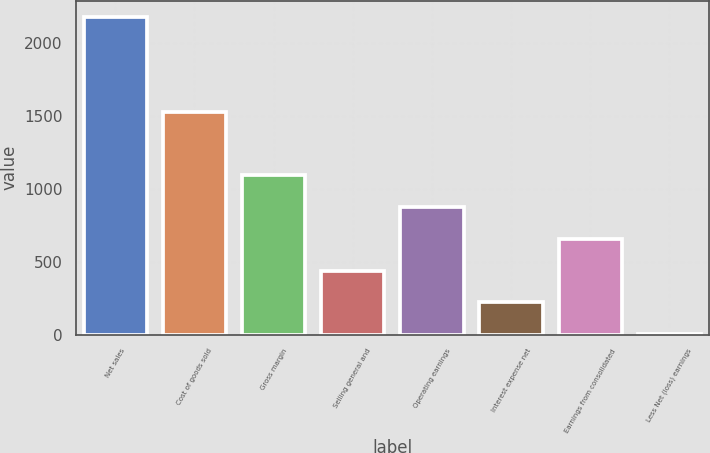<chart> <loc_0><loc_0><loc_500><loc_500><bar_chart><fcel>Net sales<fcel>Cost of goods sold<fcel>Gross margin<fcel>Selling general and<fcel>Operating earnings<fcel>Interest expense net<fcel>Earnings from consolidated<fcel>Less Net (loss) earnings<nl><fcel>2177.9<fcel>1522.3<fcel>1090.5<fcel>438.06<fcel>873.02<fcel>220.58<fcel>655.54<fcel>3.1<nl></chart> 